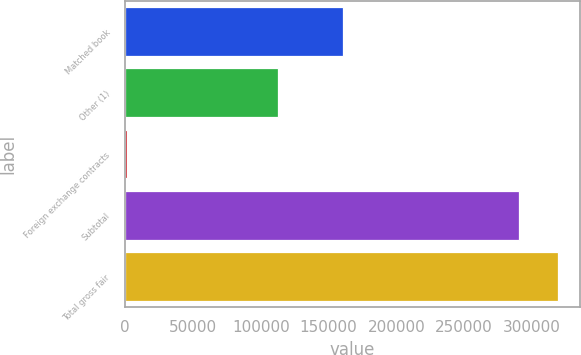<chart> <loc_0><loc_0><loc_500><loc_500><bar_chart><fcel>Matched book<fcel>Other (1)<fcel>Foreign exchange contracts<fcel>Subtotal<fcel>Total gross fair<nl><fcel>160345<fcel>112864<fcel>1454<fcel>290243<fcel>319474<nl></chart> 